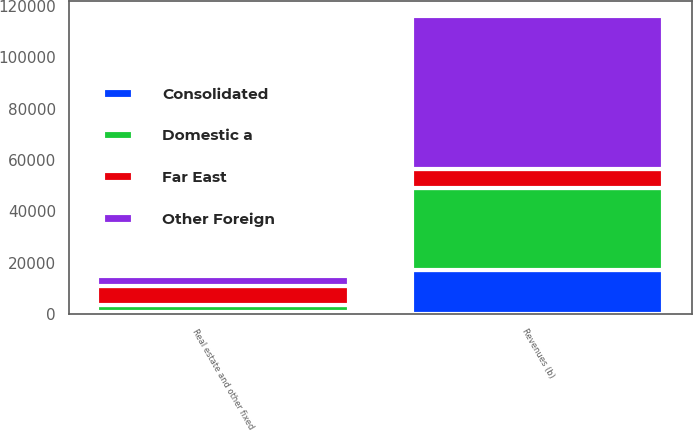Convert chart. <chart><loc_0><loc_0><loc_500><loc_500><stacked_bar_chart><ecel><fcel>Revenues (b)<fcel>Real estate and other fixed<nl><fcel>Other Foreign<fcel>59858<fcel>3840<nl><fcel>Domestic a<fcel>32036<fcel>2669<nl><fcel>Consolidated<fcel>17011<fcel>937<nl><fcel>Far East<fcel>7446<fcel>7446<nl></chart> 